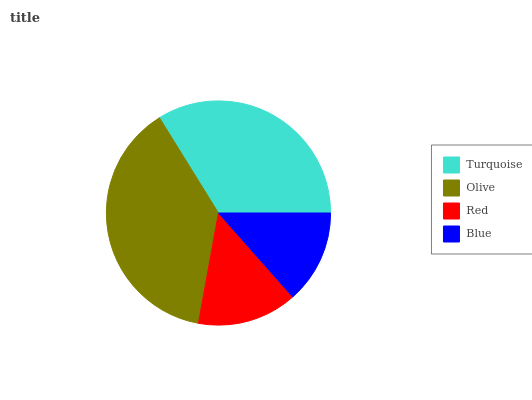Is Blue the minimum?
Answer yes or no. Yes. Is Olive the maximum?
Answer yes or no. Yes. Is Red the minimum?
Answer yes or no. No. Is Red the maximum?
Answer yes or no. No. Is Olive greater than Red?
Answer yes or no. Yes. Is Red less than Olive?
Answer yes or no. Yes. Is Red greater than Olive?
Answer yes or no. No. Is Olive less than Red?
Answer yes or no. No. Is Turquoise the high median?
Answer yes or no. Yes. Is Red the low median?
Answer yes or no. Yes. Is Blue the high median?
Answer yes or no. No. Is Turquoise the low median?
Answer yes or no. No. 